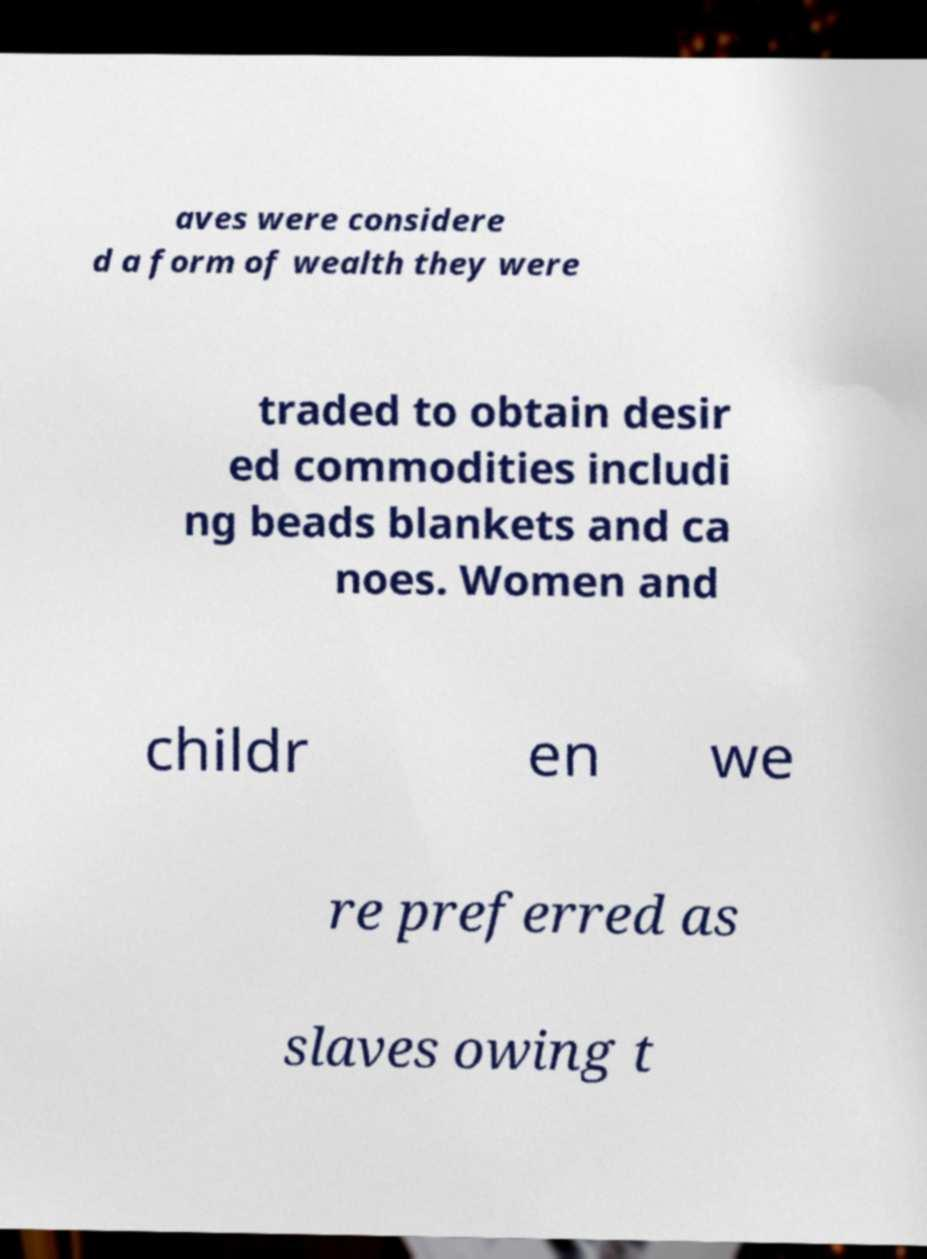I need the written content from this picture converted into text. Can you do that? aves were considere d a form of wealth they were traded to obtain desir ed commodities includi ng beads blankets and ca noes. Women and childr en we re preferred as slaves owing t 